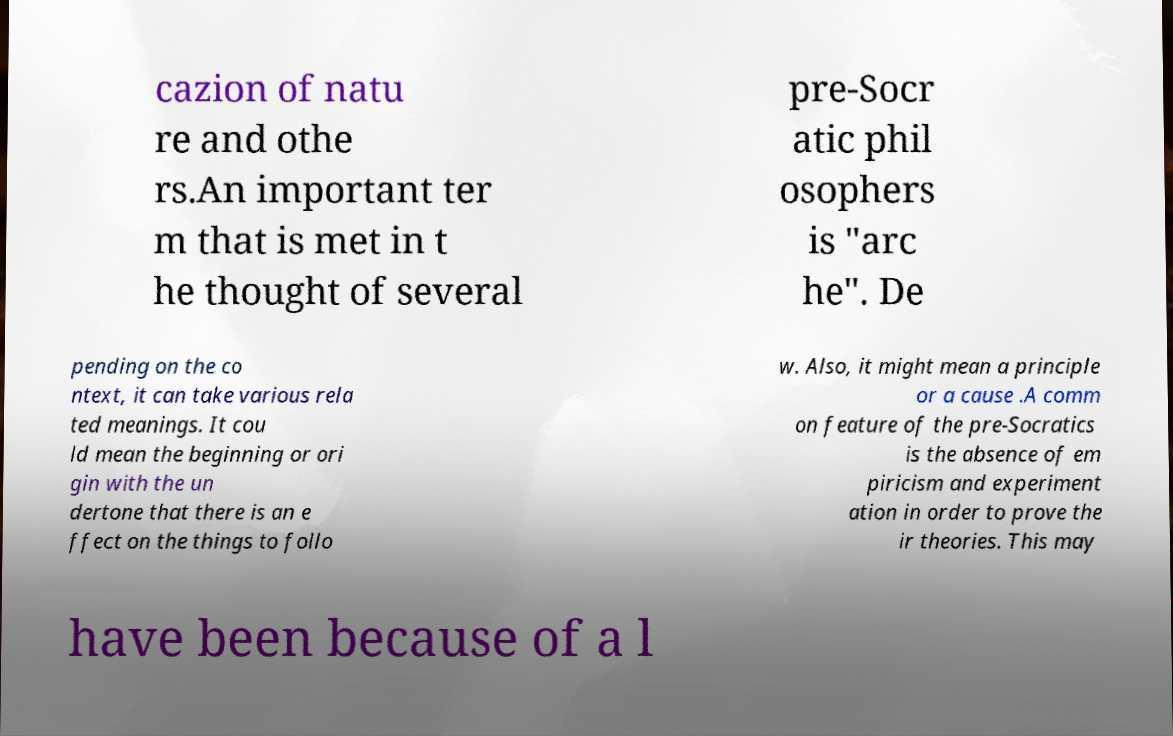I need the written content from this picture converted into text. Can you do that? cazion of natu re and othe rs.An important ter m that is met in t he thought of several pre-Socr atic phil osophers is "arc he". De pending on the co ntext, it can take various rela ted meanings. It cou ld mean the beginning or ori gin with the un dertone that there is an e ffect on the things to follo w. Also, it might mean a principle or a cause .A comm on feature of the pre-Socratics is the absence of em piricism and experiment ation in order to prove the ir theories. This may have been because of a l 